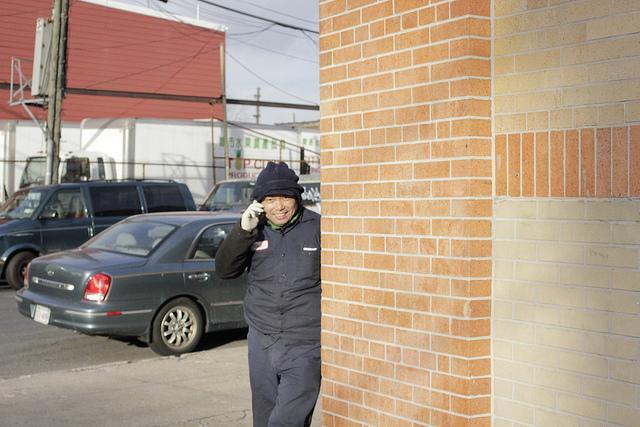How many cars can be seen?
Give a very brief answer. 3. How many cars are visible?
Give a very brief answer. 2. 